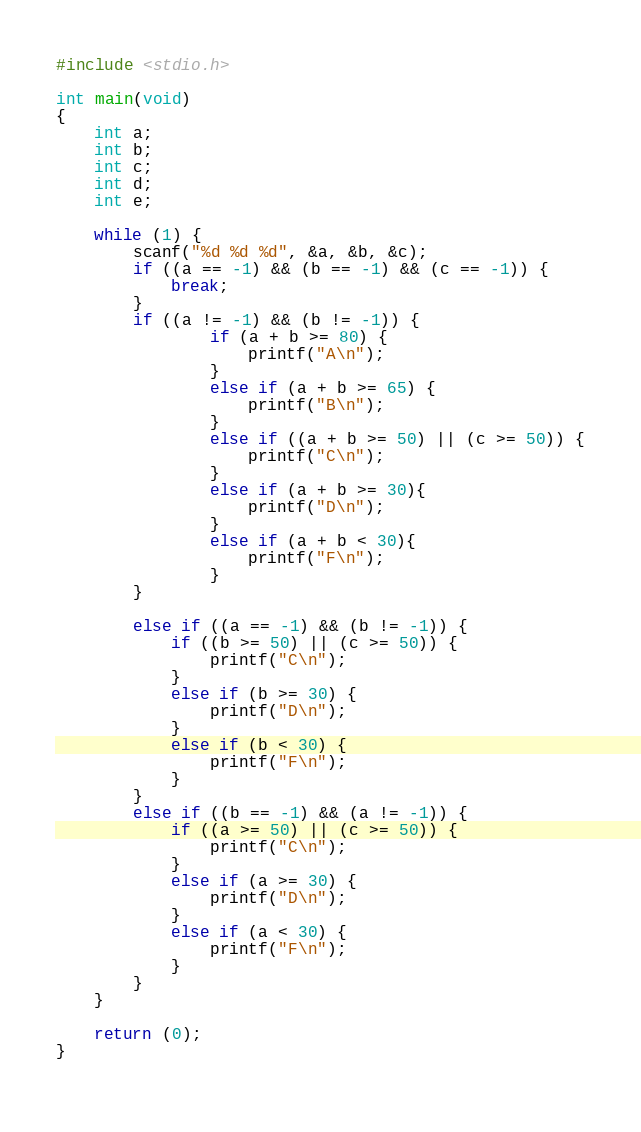Convert code to text. <code><loc_0><loc_0><loc_500><loc_500><_C_>#include <stdio.h>

int main(void)
{
	int a;
	int b;
	int c;
	int d;
	int e;
	
	while (1) {
		scanf("%d %d %d", &a, &b, &c);
		if ((a == -1) && (b == -1) && (c == -1)) {
			break;
		}
		if ((a != -1) && (b != -1)) {
				if (a + b >= 80) {
					printf("A\n");
				}
				else if (a + b >= 65) {
					printf("B\n");
				}
				else if ((a + b >= 50) || (c >= 50)) {
					printf("C\n");
				}
				else if (a + b >= 30){
					printf("D\n");
				}
				else if (a + b < 30){
					printf("F\n");
				}
		}
		
		else if ((a == -1) && (b != -1)) {
			if ((b >= 50) || (c >= 50)) {
				printf("C\n");
			}
			else if (b >= 30) {
				printf("D\n");
			}
			else if (b < 30) {
				printf("F\n");
			}
		}
		else if ((b == -1) && (a != -1)) {
			if ((a >= 50) || (c >= 50)) {
				printf("C\n");
			}
			else if (a >= 30) {
				printf("D\n");
			}
			else if (a < 30) {
				printf("F\n");
			}
		}
	}
	
	return (0);
}		
		</code> 